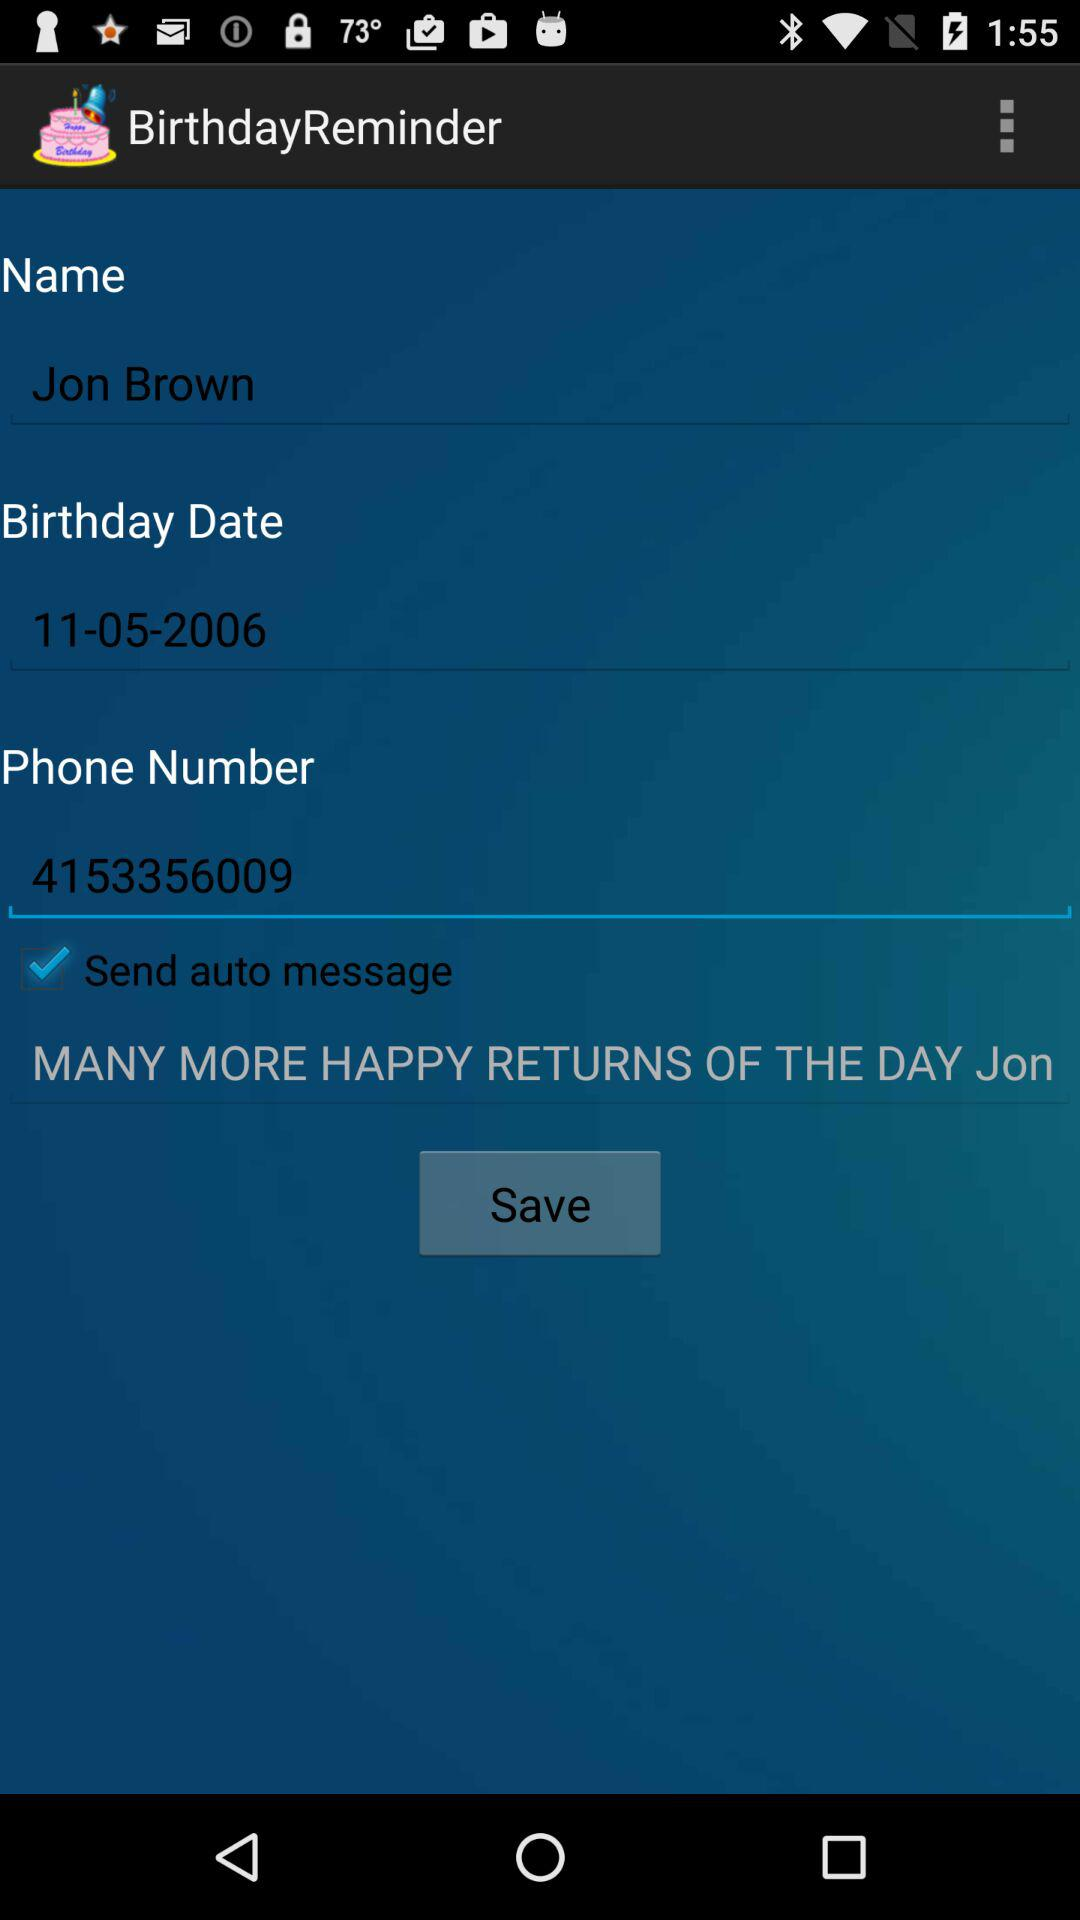What's the status of "Send auto message"? The status is "on". 